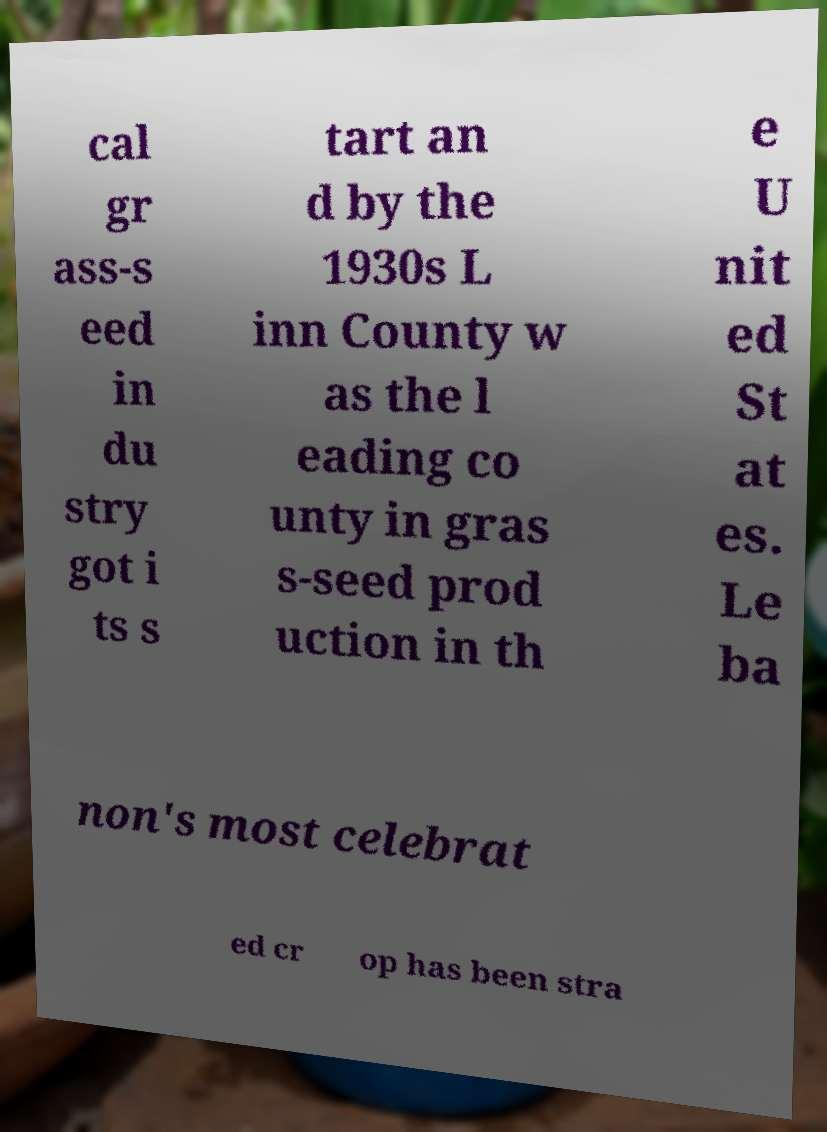Can you read and provide the text displayed in the image?This photo seems to have some interesting text. Can you extract and type it out for me? cal gr ass-s eed in du stry got i ts s tart an d by the 1930s L inn County w as the l eading co unty in gras s-seed prod uction in th e U nit ed St at es. Le ba non's most celebrat ed cr op has been stra 